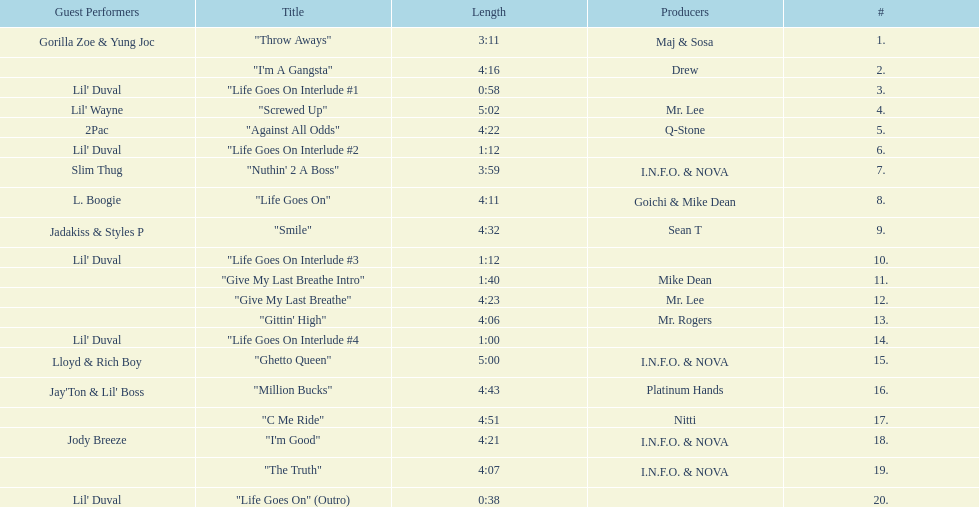What is the total number of tracks on the album? 20. Could you help me parse every detail presented in this table? {'header': ['Guest Performers', 'Title', 'Length', 'Producers', '#'], 'rows': [['Gorilla Zoe & Yung Joc', '"Throw Aways"', '3:11', 'Maj & Sosa', '1.'], ['', '"I\'m A Gangsta"', '4:16', 'Drew', '2.'], ["Lil' Duval", '"Life Goes On Interlude #1', '0:58', '', '3.'], ["Lil' Wayne", '"Screwed Up"', '5:02', 'Mr. Lee', '4.'], ['2Pac', '"Against All Odds"', '4:22', 'Q-Stone', '5.'], ["Lil' Duval", '"Life Goes On Interlude #2', '1:12', '', '6.'], ['Slim Thug', '"Nuthin\' 2 A Boss"', '3:59', 'I.N.F.O. & NOVA', '7.'], ['L. Boogie', '"Life Goes On"', '4:11', 'Goichi & Mike Dean', '8.'], ['Jadakiss & Styles P', '"Smile"', '4:32', 'Sean T', '9.'], ["Lil' Duval", '"Life Goes On Interlude #3', '1:12', '', '10.'], ['', '"Give My Last Breathe Intro"', '1:40', 'Mike Dean', '11.'], ['', '"Give My Last Breathe"', '4:23', 'Mr. Lee', '12.'], ['', '"Gittin\' High"', '4:06', 'Mr. Rogers', '13.'], ["Lil' Duval", '"Life Goes On Interlude #4', '1:00', '', '14.'], ['Lloyd & Rich Boy', '"Ghetto Queen"', '5:00', 'I.N.F.O. & NOVA', '15.'], ["Jay'Ton & Lil' Boss", '"Million Bucks"', '4:43', 'Platinum Hands', '16.'], ['', '"C Me Ride"', '4:51', 'Nitti', '17.'], ['Jody Breeze', '"I\'m Good"', '4:21', 'I.N.F.O. & NOVA', '18.'], ['', '"The Truth"', '4:07', 'I.N.F.O. & NOVA', '19.'], ["Lil' Duval", '"Life Goes On" (Outro)', '0:38', '', '20.']]} 